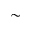<formula> <loc_0><loc_0><loc_500><loc_500>\sim</formula> 